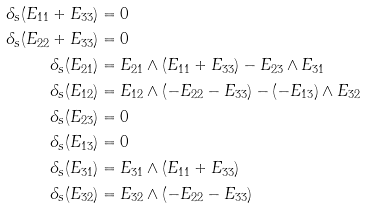Convert formula to latex. <formula><loc_0><loc_0><loc_500><loc_500>\delta _ { s } ( E _ { 1 1 } + E _ { 3 3 } ) & = 0 \\ \delta _ { s } ( E _ { 2 2 } + E _ { 3 3 } ) & = 0 \\ \delta _ { s } ( E _ { 2 1 } ) & = E _ { 2 1 } \wedge ( E _ { 1 1 } + E _ { 3 3 } ) - E _ { 2 3 } \wedge E _ { 3 1 } \\ \delta _ { s } ( E _ { 1 2 } ) & = E _ { 1 2 } \wedge ( - E _ { 2 2 } - E _ { 3 3 } ) - ( - E _ { 1 3 } ) \wedge E _ { 3 2 } \\ \delta _ { s } ( E _ { 2 3 } ) & = 0 \\ \delta _ { s } ( E _ { 1 3 } ) & = 0 \\ \delta _ { s } ( E _ { 3 1 } ) & = E _ { 3 1 } \wedge ( E _ { 1 1 } + E _ { 3 3 } ) \\ \delta _ { s } ( E _ { 3 2 } ) & = E _ { 3 2 } \wedge ( - E _ { 2 2 } - E _ { 3 3 } )</formula> 